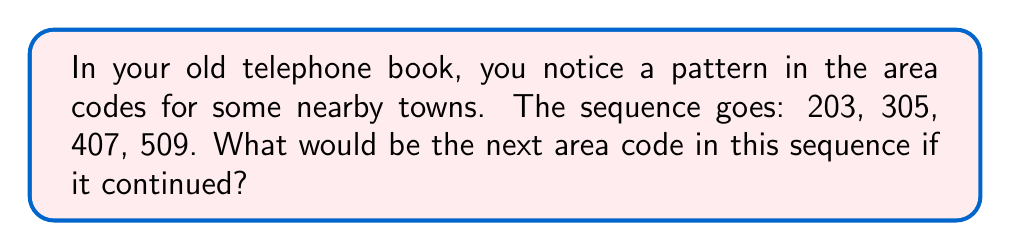Help me with this question. Let's analyze this sequence step-by-step:

1) First, let's look at the difference between each consecutive pair of numbers:

   305 - 203 = 102
   407 - 305 = 102
   509 - 407 = 102

2) We can see that the difference is constant: 102.

3) This means we have an arithmetic sequence where each term is found by adding 102 to the previous term.

4) To find the next term, we add 102 to the last given term:

   $509 + 102 = 611$

5) Therefore, the next area code in the sequence would be 611.

This pattern might seem unnecessarily complicated for area codes, but it's important to remember that in the old days, area codes were assigned in a more systematic way to make them easier to remember and dial on rotary phones.
Answer: 611 